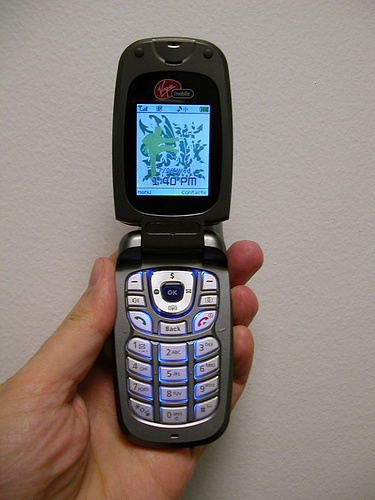Describe the objects in this image and their specific colors. I can see cell phone in gray, black, darkgray, and lavender tones and people in gray, brown, maroon, and black tones in this image. 